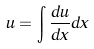<formula> <loc_0><loc_0><loc_500><loc_500>u = \int \frac { d u } { d x } d x</formula> 